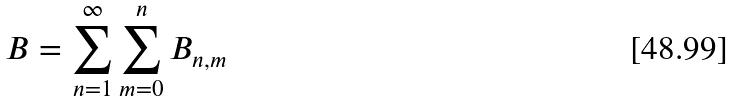<formula> <loc_0><loc_0><loc_500><loc_500>B = \sum _ { n = 1 } ^ { \infty } \sum _ { m = 0 } ^ { n } B _ { n , m }</formula> 